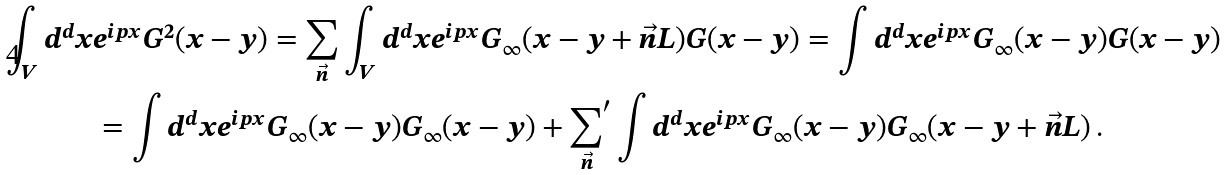Convert formula to latex. <formula><loc_0><loc_0><loc_500><loc_500>\int _ { V } d ^ { d } x & e ^ { i p x } G ^ { 2 } ( x - y ) = \sum _ { \vec { n } } \int _ { V } d ^ { d } x e ^ { i p x } G _ { \infty } ( x - y + \vec { n } L ) G ( x - y ) = \int d ^ { d } x e ^ { i p x } G _ { \infty } ( x - y ) G ( x - y ) \\ & = \int d ^ { d } x e ^ { i p x } G _ { \infty } ( x - y ) G _ { \infty } ( x - y ) + { \sum _ { \vec { n } } } ^ { \prime } \int d ^ { d } x e ^ { i p x } G _ { \infty } ( x - y ) G _ { \infty } ( x - y + \vec { n } L ) \, .</formula> 